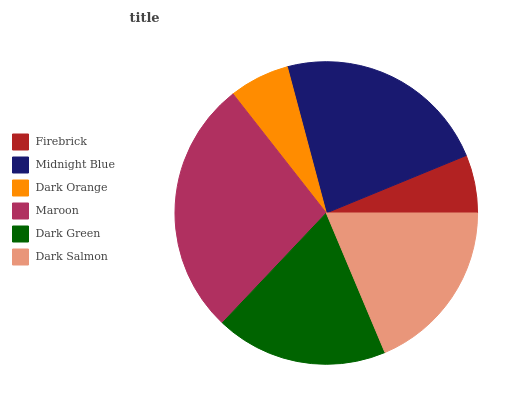Is Firebrick the minimum?
Answer yes or no. Yes. Is Maroon the maximum?
Answer yes or no. Yes. Is Midnight Blue the minimum?
Answer yes or no. No. Is Midnight Blue the maximum?
Answer yes or no. No. Is Midnight Blue greater than Firebrick?
Answer yes or no. Yes. Is Firebrick less than Midnight Blue?
Answer yes or no. Yes. Is Firebrick greater than Midnight Blue?
Answer yes or no. No. Is Midnight Blue less than Firebrick?
Answer yes or no. No. Is Dark Salmon the high median?
Answer yes or no. Yes. Is Dark Green the low median?
Answer yes or no. Yes. Is Maroon the high median?
Answer yes or no. No. Is Firebrick the low median?
Answer yes or no. No. 